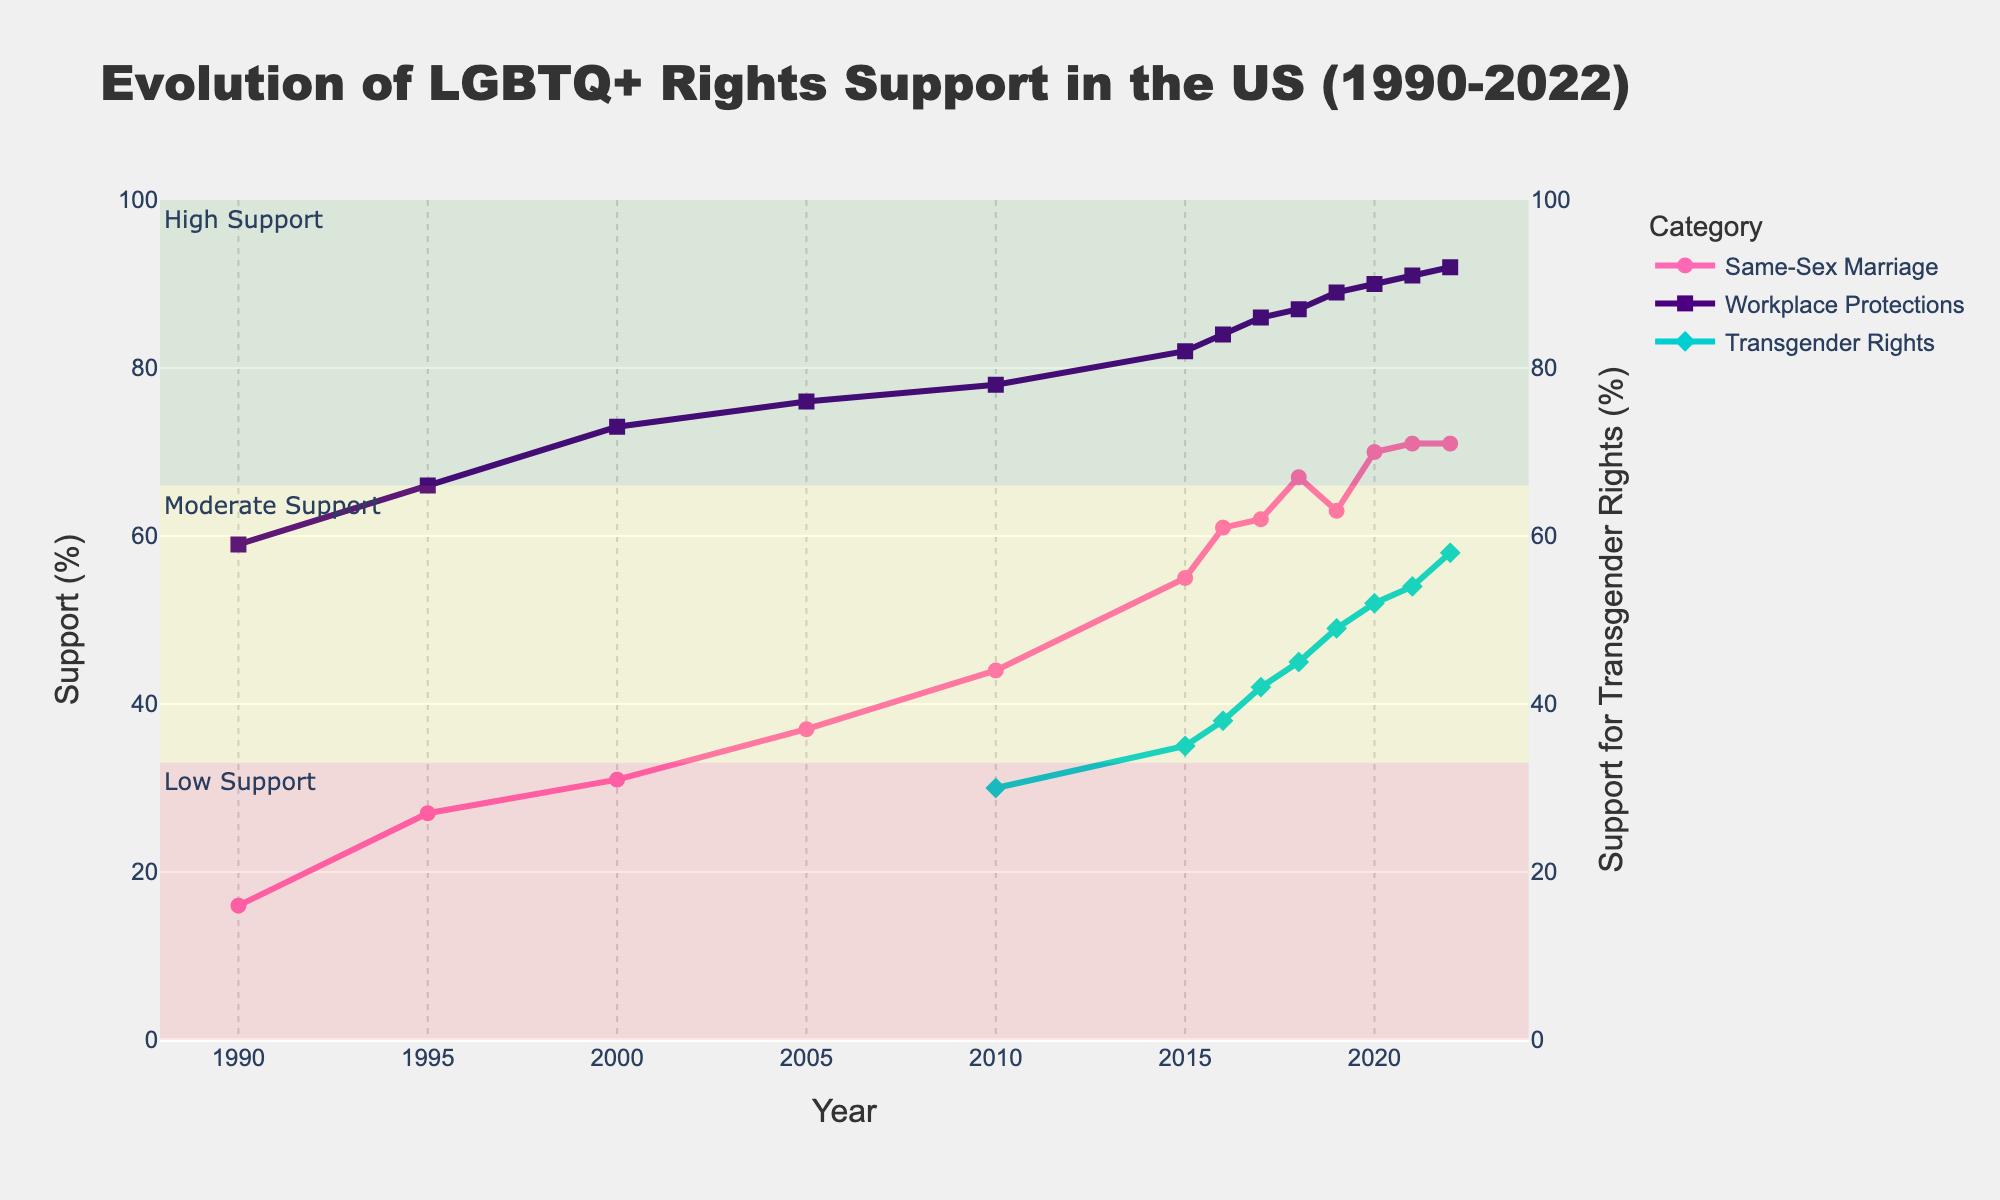What's the highest percentage of support for same-sex marriage recorded in the chart? The figure shows the evolution of support for same-sex marriage with a line plot in pink. The highest point on this line, based on the data, can be found in the year 2022, where the support is at its maximum.
Answer: 71% Compare the support for LGBTQ+ workplace protections and same-sex marriage in 2022. Which one has higher support? In 2022, the support for same-sex marriage is shown by the pink line, and the support for LGBTQ+ workplace protections is shown by the indigo line. By observing their endpoints in 2022, it is evident that the indigo line (workplace protections) is higher.
Answer: LGBTQ+ workplace protections When did the support for transgender rights begin to be recorded, and what was the initial percentage? The figure includes support for transgender rights starting in the year 2010, marked by a diamond symbol along a cyan line. The initial recorded support percentage in 2010 can be seen from this line.
Answer: 30% Calculate the average support for same-sex marriage over the first five years shown (1990-2010). The support percentages for same-sex marriage from 1990 to 2010 are 16%, 27%, 31%, 37%, and 44%. The sum of these values is 155%, and there are 5 years. Therefore, the average support is 155% / 5.
Answer: 31% Compare the growth rate of support for same-sex marriage between 1990-2000 and 2000-2010. Which decade had a faster growth rate? By looking at the pink line, the increase from 1990 (16%) to 2000 (31%) is 15 percentage points, and from 2000 (31%) to 2010 (44%) is 13 percentage points. Compare these two increases.
Answer: 1990-2000 Which category reached above 70% support first, and in what year did this occur? The category lines show support percentages over time. The indigo line (workplace protections) reaches above the 70% mark first. By checking the timeline, this occurs around the year 2000.
Answer: LGBTQ+ workplace protections in 2000 Has the support for any category ever decreased in any year? If so, which category and when? By tracking the trajectory of each line, small dips indicate decreases in support. The pink line for same-sex marriage shows a slight dip between 2018 and 2019.
Answer: Same-sex marriage between 2018 and 2019 Between 2010 and 2022, by how many percentage points did support for LGBTQ+ workplace protections increase? In the year 2010, support for workplace protections was 78%, and in 2022 it was 92%. Subtract the earlier value from the later one to find the increase: 92% - 78%.
Answer: 14 percentage points Based on the chart, can you identify any category that has consistently been in the "High Support" range since 2005? The high support range is shaded green. The indigo line representing LGBTQ+ workplace protections has been consistently within this range since 2005.
Answer: LGBTQ+ workplace protections What is the general trend observed for all three categories of support from 1990 to 2022? Inspecting the overall directions of all three lines, each category shows an upward trend, signifying increasing support over the years.
Answer: Increasing 